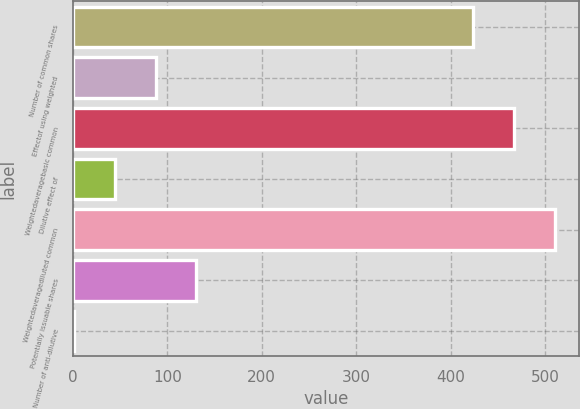<chart> <loc_0><loc_0><loc_500><loc_500><bar_chart><fcel>Number of common shares<fcel>Effectof using weighted<fcel>Weightedaveragebasic common<fcel>Dilutive effect of<fcel>Weightedaveragediluted common<fcel>Potentially issuable shares<fcel>Number of anti-dilutive<nl><fcel>424<fcel>87.64<fcel>467.07<fcel>44.57<fcel>510.14<fcel>130.71<fcel>1.5<nl></chart> 